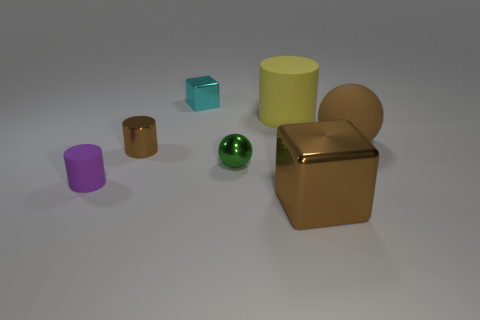How many shiny cubes are the same color as the big cylinder?
Provide a short and direct response. 0. There is a brown shiny cube; is its size the same as the brown ball right of the large cylinder?
Your response must be concise. Yes. There is a cube that is on the right side of the block that is on the left side of the shiny block that is in front of the cyan metal thing; what is its size?
Your response must be concise. Large. How many tiny rubber cylinders are behind the tiny brown metallic cylinder?
Your answer should be compact. 0. What is the brown thing that is left of the tiny block that is behind the yellow rubber cylinder made of?
Offer a terse response. Metal. Is there anything else that is the same size as the green metallic thing?
Your response must be concise. Yes. Is the size of the yellow cylinder the same as the metal sphere?
Keep it short and to the point. No. How many objects are shiny things that are behind the big yellow matte thing or big objects in front of the large matte cylinder?
Your answer should be very brief. 3. Are there more small brown cylinders on the right side of the brown rubber sphere than big metal cubes?
Your response must be concise. No. How many other things are there of the same shape as the cyan shiny object?
Keep it short and to the point. 1. 